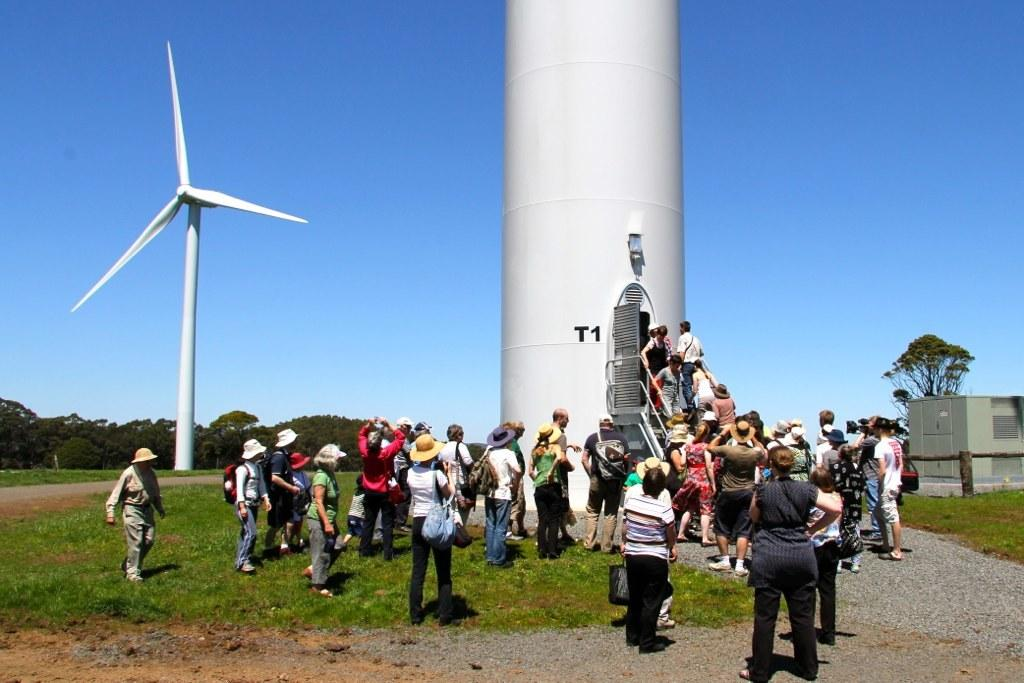What structures can be seen in the image? There are windmills in the image. What else is present in the image besides the windmills? There is a group of people in the image, and some of them are wearing caps. Where is the house located in the image? The house is on the right side of the image. What can be seen in the background of the image? There are trees in the background of the image. What type of religious treatment is being performed by the people in the image? There is no indication of any religious treatment being performed in the image; it simply shows windmills, a group of people, a house, and trees. 